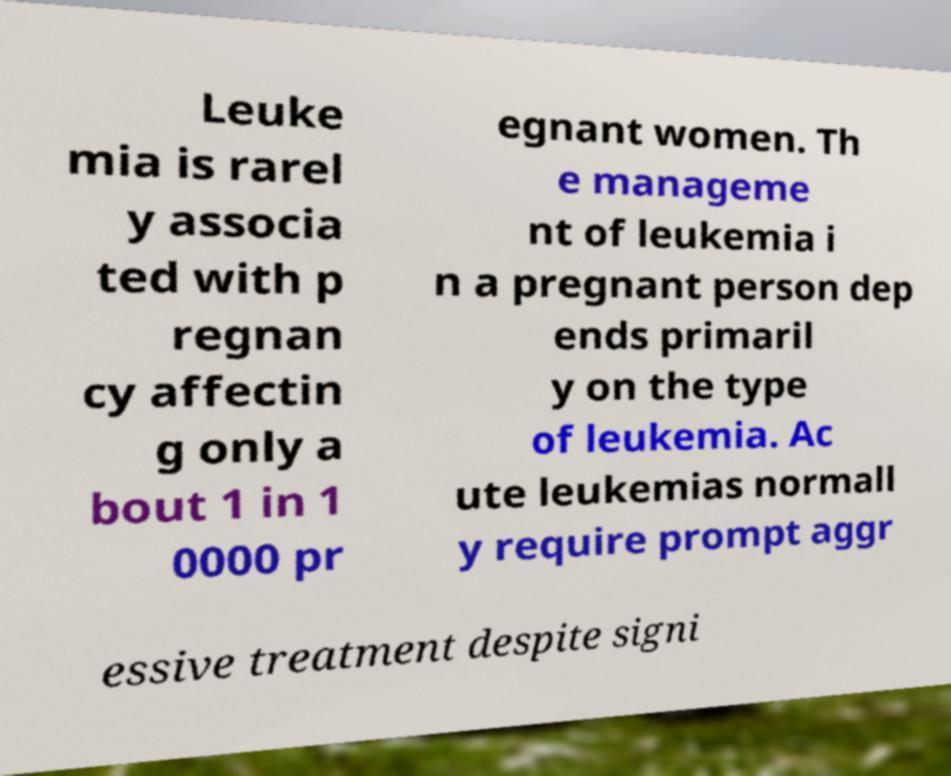I need the written content from this picture converted into text. Can you do that? Leuke mia is rarel y associa ted with p regnan cy affectin g only a bout 1 in 1 0000 pr egnant women. Th e manageme nt of leukemia i n a pregnant person dep ends primaril y on the type of leukemia. Ac ute leukemias normall y require prompt aggr essive treatment despite signi 